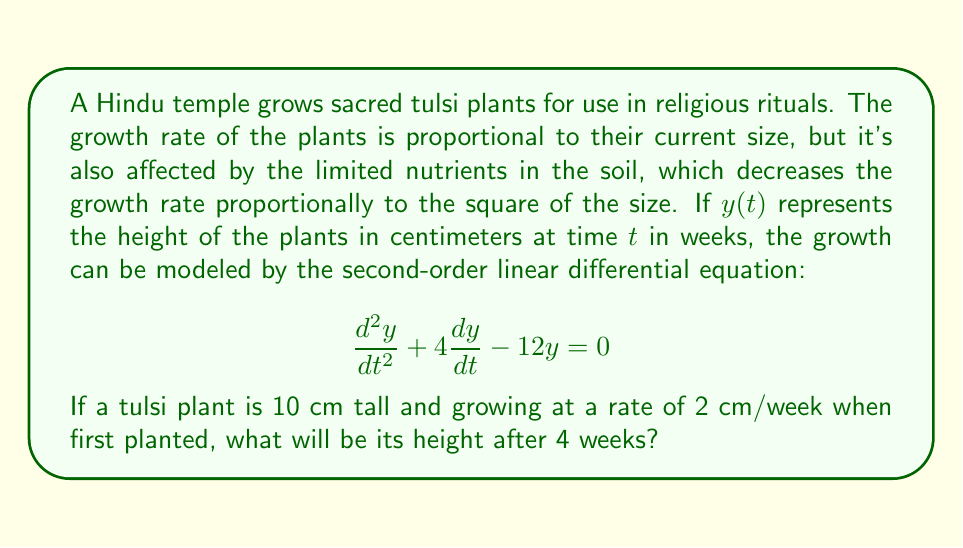Show me your answer to this math problem. To solve this problem, we need to follow these steps:

1) First, we need to find the general solution to the differential equation. The characteristic equation is:

   $$r^2 + 4r - 12 = 0$$

2) Solving this quadratic equation:
   
   $$r = \frac{-4 \pm \sqrt{16 + 48}}{2} = \frac{-4 \pm \sqrt{64}}{2} = \frac{-4 \pm 8}{2}$$

   So, $r_1 = 2$ and $r_2 = -6$

3) The general solution is therefore:

   $$y(t) = c_1e^{2t} + c_2e^{-6t}$$

4) We need to use the initial conditions to find $c_1$ and $c_2$. We know that:

   At $t=0$, $y(0) = 10$ and $y'(0) = 2$

5) Using $y(0) = 10$:

   $$10 = c_1 + c_2$$

6) Using $y'(0) = 2$:

   $$y'(t) = 2c_1e^{2t} - 6c_2e^{-6t}$$
   $$2 = 2c_1 - 6c_2$$

7) Now we have a system of two equations:

   $$c_1 + c_2 = 10$$
   $$2c_1 - 6c_2 = 2$$

8) Solving this system:

   Multiply the first equation by 2: $2c_1 + 2c_2 = 20$
   Subtract the second equation: $8c_2 = 18$
   $c_2 = \frac{9}{4}$

   Substitute back: $c_1 = 10 - \frac{9}{4} = \frac{31}{4}$

9) Therefore, the particular solution is:

   $$y(t) = \frac{31}{4}e^{2t} + \frac{9}{4}e^{-6t}$$

10) To find the height after 4 weeks, we substitute $t=4$:

    $$y(4) = \frac{31}{4}e^{8} + \frac{9}{4}e^{-24}$$

11) Calculate this value:

    $$y(4) \approx 2980.96 + 0.00 \approx 2980.96$$
Answer: The height of the tulsi plant after 4 weeks will be approximately 2980.96 cm. 